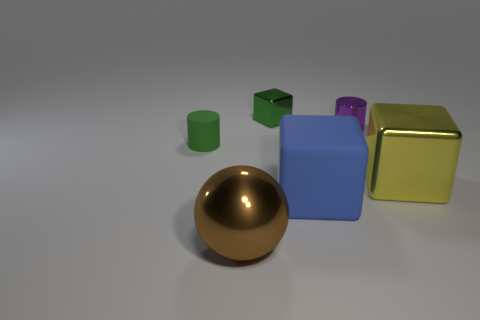There is a big shiny thing that is on the left side of the tiny metal block; what is its color?
Provide a succinct answer. Brown. How many big cyan matte balls are there?
Ensure brevity in your answer.  0. There is a big metal object right of the shiny block that is left of the purple metal thing; is there a metallic object left of it?
Keep it short and to the point. Yes. The shiny thing that is the same size as the purple shiny cylinder is what shape?
Ensure brevity in your answer.  Cube. What number of other things are the same color as the tiny matte cylinder?
Give a very brief answer. 1. What material is the big brown sphere?
Make the answer very short. Metal. How many other objects are the same material as the small purple cylinder?
Your answer should be compact. 3. There is a thing that is left of the small metal cube and behind the blue object; what size is it?
Offer a very short reply. Small. The large blue thing in front of the green object that is behind the tiny green rubber cylinder is what shape?
Give a very brief answer. Cube. Is there anything else that is the same shape as the brown metal object?
Make the answer very short. No. 